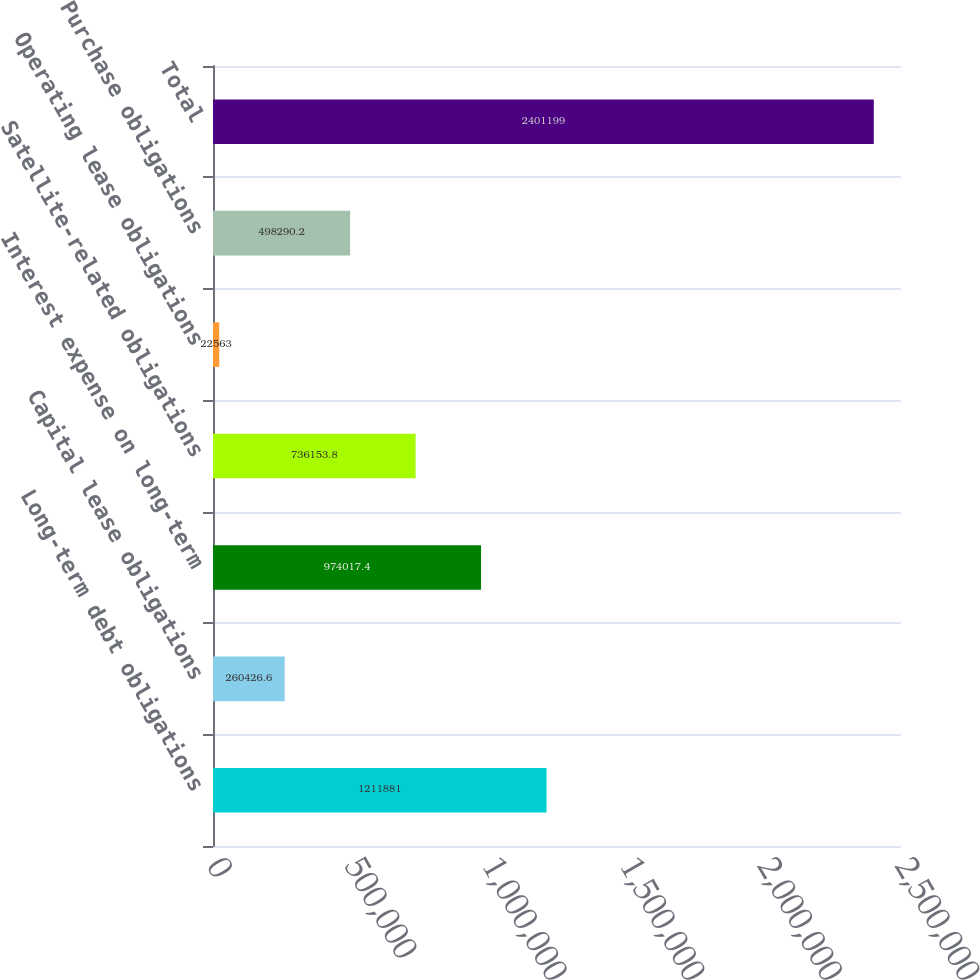Convert chart. <chart><loc_0><loc_0><loc_500><loc_500><bar_chart><fcel>Long-term debt obligations<fcel>Capital lease obligations<fcel>Interest expense on long-term<fcel>Satellite-related obligations<fcel>Operating lease obligations<fcel>Purchase obligations<fcel>Total<nl><fcel>1.21188e+06<fcel>260427<fcel>974017<fcel>736154<fcel>22563<fcel>498290<fcel>2.4012e+06<nl></chart> 